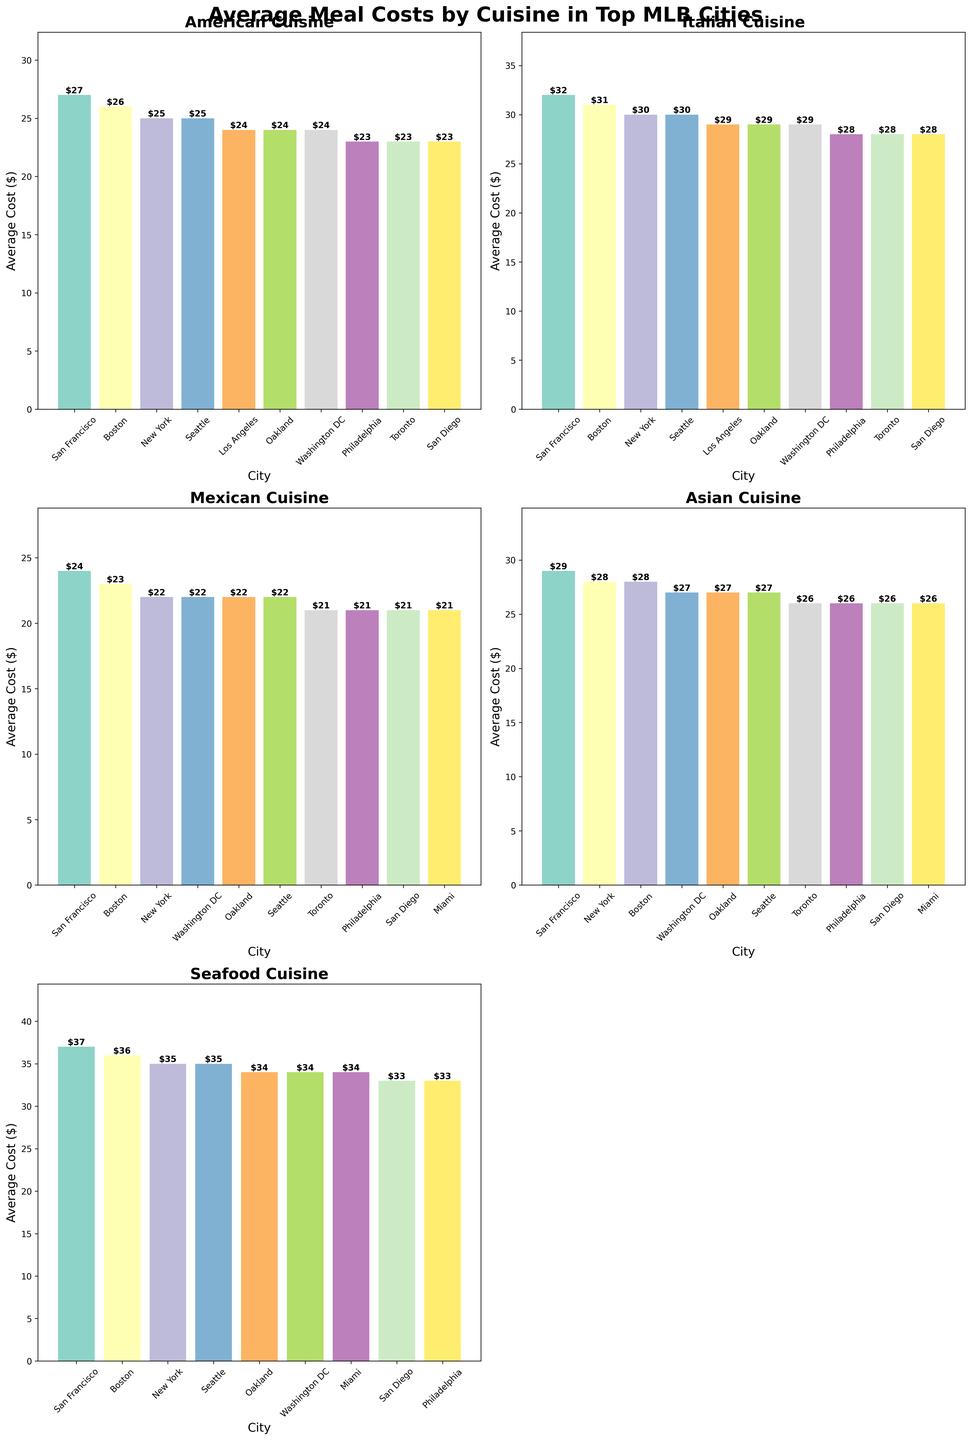Which city has the highest average cost for Asian cuisine? The subplot for Asian cuisine will show the bars representing the costs for the top cities. The tallest bar indicates the city with the highest cost. By looking at the figure, San Francisco has the highest bar.
Answer: San Francisco Compare the costs for Italian and Seafood cuisines in Boston. Which one is higher? In the subplots for Italian and Seafood cuisines, locate Boston. Observe the heights of the bars. For Italian, the cost is at $31, and for Seafood, it is $36. The taller bar indicates the higher cost.
Answer: Seafood What's the difference in the average meal cost for Mexican cuisine between New York and Detroit? Find Detroit and New York in the Mexican cuisine subplot. The height of the bar for New York is $22, and for Detroit, it is $17. Subtract $17 from $22 to find the difference.
Answer: $5 Which cuisine has the smallest maximum average meal cost among all top cities? For each subplot, identify the maximum average meal cost by looking at the tallest bars. Compare these values across all cuisines. The smallest maximum value is in the Mexican cuisine subplot with $24.
Answer: Mexican How does the average cost of American cuisine compare between Seattle and Miami? Locate Seattle and Miami in the American cuisine subplot. The heights of the bars indicate their costs: both are $25.
Answer: Equal If you combine the costs of Asian cuisine in Houston and Washington DC, what is the total? From the Asian cuisine subplot, identify the costs for Houston ($24) and Washington DC ($27). Add these two values together: $24 + $27.
Answer: $51 Which city appears most frequently among the top 10 cities across all cuisines? Identify the cities listed across the top 10 for each cuisine subplot. Count the frequency of each city's appearance. New York and Boston have the most frequent appearances.
Answer: New York, Boston What is the average cost of Italian cuisine across the top five cities? Identify the top five cities in the Italian cuisine subplot and their respective costs: San Francisco ($32), Boston ($31), New York ($30), Seattle ($30), and Los Angeles ($29). Calculate the average of these values: ($32 + $31 + $30 + $30 + $29) / 5.
Answer: $30.4 Which city has the lowest cost for Seafood cuisine among the top 10 cities? In the Seafood cuisine subplot, look for the smallest bar among the top 10 cities. The lowest cost within this subtree is Washington DC with $31.
Answer: Washington DC 